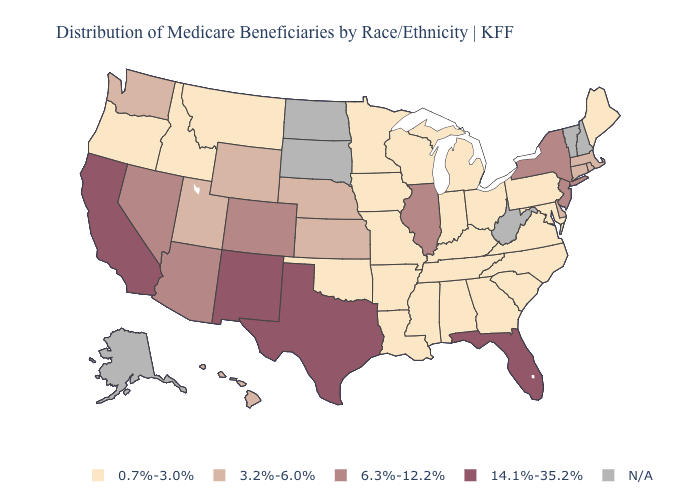Does the first symbol in the legend represent the smallest category?
Concise answer only. Yes. Does the map have missing data?
Keep it brief. Yes. Name the states that have a value in the range 3.2%-6.0%?
Be succinct. Connecticut, Delaware, Hawaii, Kansas, Massachusetts, Nebraska, Rhode Island, Utah, Washington, Wyoming. Name the states that have a value in the range 14.1%-35.2%?
Write a very short answer. California, Florida, New Mexico, Texas. What is the value of North Dakota?
Be succinct. N/A. Which states have the highest value in the USA?
Keep it brief. California, Florida, New Mexico, Texas. Among the states that border Texas , does New Mexico have the lowest value?
Concise answer only. No. What is the value of Rhode Island?
Answer briefly. 3.2%-6.0%. What is the lowest value in states that border Vermont?
Quick response, please. 3.2%-6.0%. Name the states that have a value in the range 3.2%-6.0%?
Keep it brief. Connecticut, Delaware, Hawaii, Kansas, Massachusetts, Nebraska, Rhode Island, Utah, Washington, Wyoming. Does Kentucky have the lowest value in the USA?
Keep it brief. Yes. What is the value of Arkansas?
Quick response, please. 0.7%-3.0%. Does Hawaii have the lowest value in the USA?
Give a very brief answer. No. 